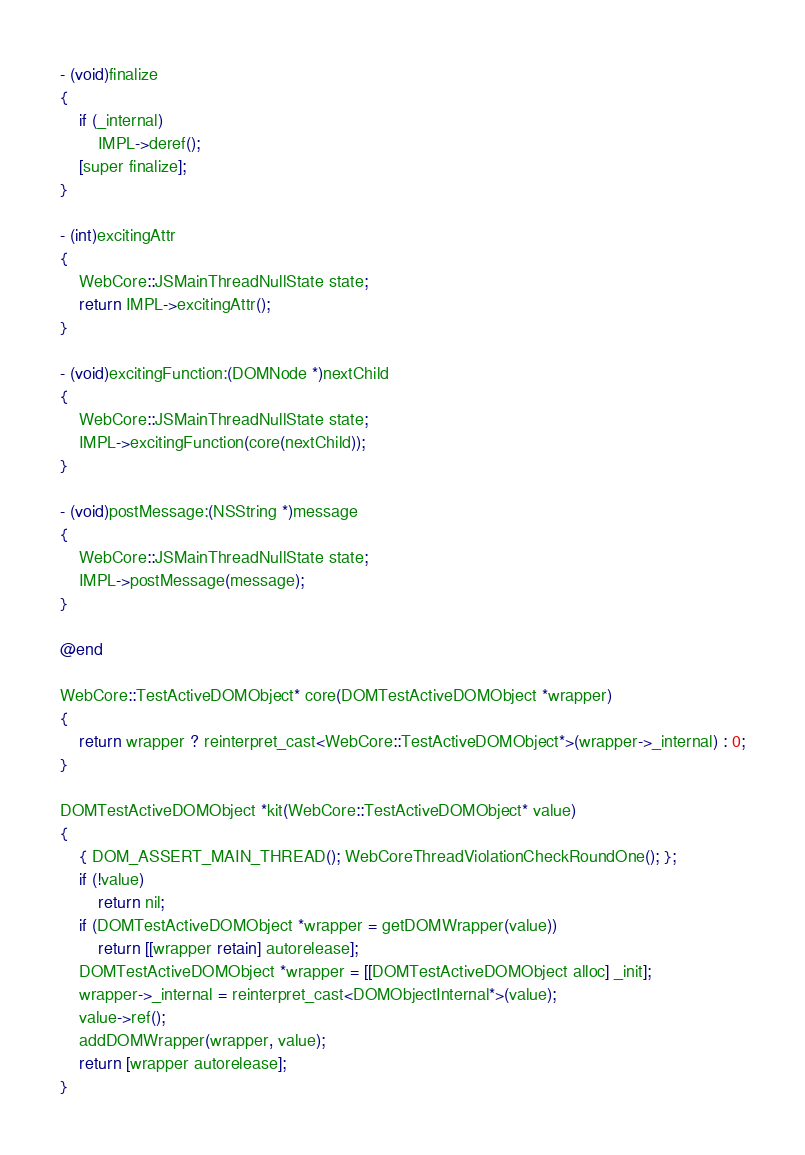Convert code to text. <code><loc_0><loc_0><loc_500><loc_500><_ObjectiveC_>- (void)finalize
{
    if (_internal)
        IMPL->deref();
    [super finalize];
}

- (int)excitingAttr
{
    WebCore::JSMainThreadNullState state;
    return IMPL->excitingAttr();
}

- (void)excitingFunction:(DOMNode *)nextChild
{
    WebCore::JSMainThreadNullState state;
    IMPL->excitingFunction(core(nextChild));
}

- (void)postMessage:(NSString *)message
{
    WebCore::JSMainThreadNullState state;
    IMPL->postMessage(message);
}

@end

WebCore::TestActiveDOMObject* core(DOMTestActiveDOMObject *wrapper)
{
    return wrapper ? reinterpret_cast<WebCore::TestActiveDOMObject*>(wrapper->_internal) : 0;
}

DOMTestActiveDOMObject *kit(WebCore::TestActiveDOMObject* value)
{
    { DOM_ASSERT_MAIN_THREAD(); WebCoreThreadViolationCheckRoundOne(); };
    if (!value)
        return nil;
    if (DOMTestActiveDOMObject *wrapper = getDOMWrapper(value))
        return [[wrapper retain] autorelease];
    DOMTestActiveDOMObject *wrapper = [[DOMTestActiveDOMObject alloc] _init];
    wrapper->_internal = reinterpret_cast<DOMObjectInternal*>(value);
    value->ref();
    addDOMWrapper(wrapper, value);
    return [wrapper autorelease];
}
</code> 